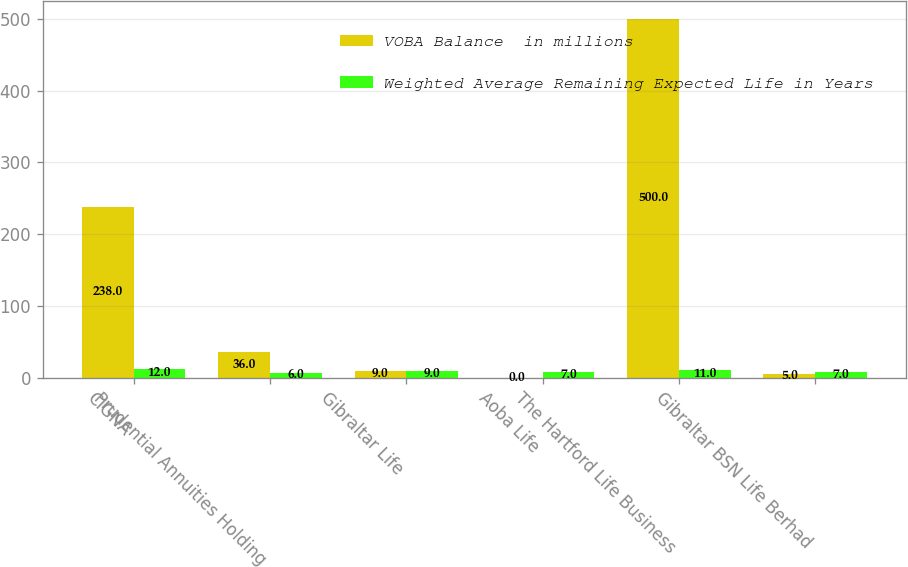Convert chart to OTSL. <chart><loc_0><loc_0><loc_500><loc_500><stacked_bar_chart><ecel><fcel>CIGNA<fcel>Prudential Annuities Holding<fcel>Gibraltar Life<fcel>Aoba Life<fcel>The Hartford Life Business<fcel>Gibraltar BSN Life Berhad<nl><fcel>VOBA Balance  in millions<fcel>238<fcel>36<fcel>9<fcel>0<fcel>500<fcel>5<nl><fcel>Weighted Average Remaining Expected Life in Years<fcel>12<fcel>6<fcel>9<fcel>7<fcel>11<fcel>7<nl></chart> 